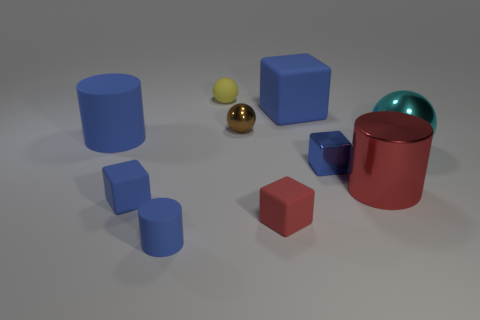What number of metallic things are small gray objects or tiny things?
Offer a terse response. 2. There is a sphere that is behind the brown ball; how many tiny blue cubes are on the left side of it?
Ensure brevity in your answer.  1. How many cubes have the same material as the yellow object?
Provide a succinct answer. 3. How many small things are yellow balls or metallic things?
Provide a short and direct response. 3. What is the shape of the blue matte object that is behind the small red thing and in front of the red shiny cylinder?
Provide a short and direct response. Cube. Is the tiny yellow thing made of the same material as the big blue cylinder?
Your response must be concise. Yes. What color is the matte sphere that is the same size as the metal cube?
Give a very brief answer. Yellow. The object that is both behind the cyan thing and on the left side of the yellow ball is what color?
Give a very brief answer. Blue. The matte block that is the same color as the big shiny cylinder is what size?
Offer a very short reply. Small. What is the shape of the tiny metal object that is the same color as the tiny cylinder?
Ensure brevity in your answer.  Cube. 